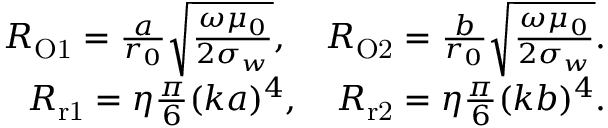<formula> <loc_0><loc_0><loc_500><loc_500>\begin{array} { r } { R _ { O 1 } = \frac { a } { r _ { 0 } } \sqrt { \frac { \omega \mu _ { 0 } } { 2 \sigma _ { w } } } , \quad R _ { O 2 } = \frac { b } { r _ { 0 } } \sqrt { \frac { \omega \mu _ { 0 } } { 2 \sigma _ { w } } } . } \\ { R _ { r 1 } = \eta \frac { \pi } { 6 } ( k a ) ^ { 4 } , \quad R _ { r 2 } = \eta \frac { \pi } { 6 } ( k b ) ^ { 4 } . } \end{array}</formula> 